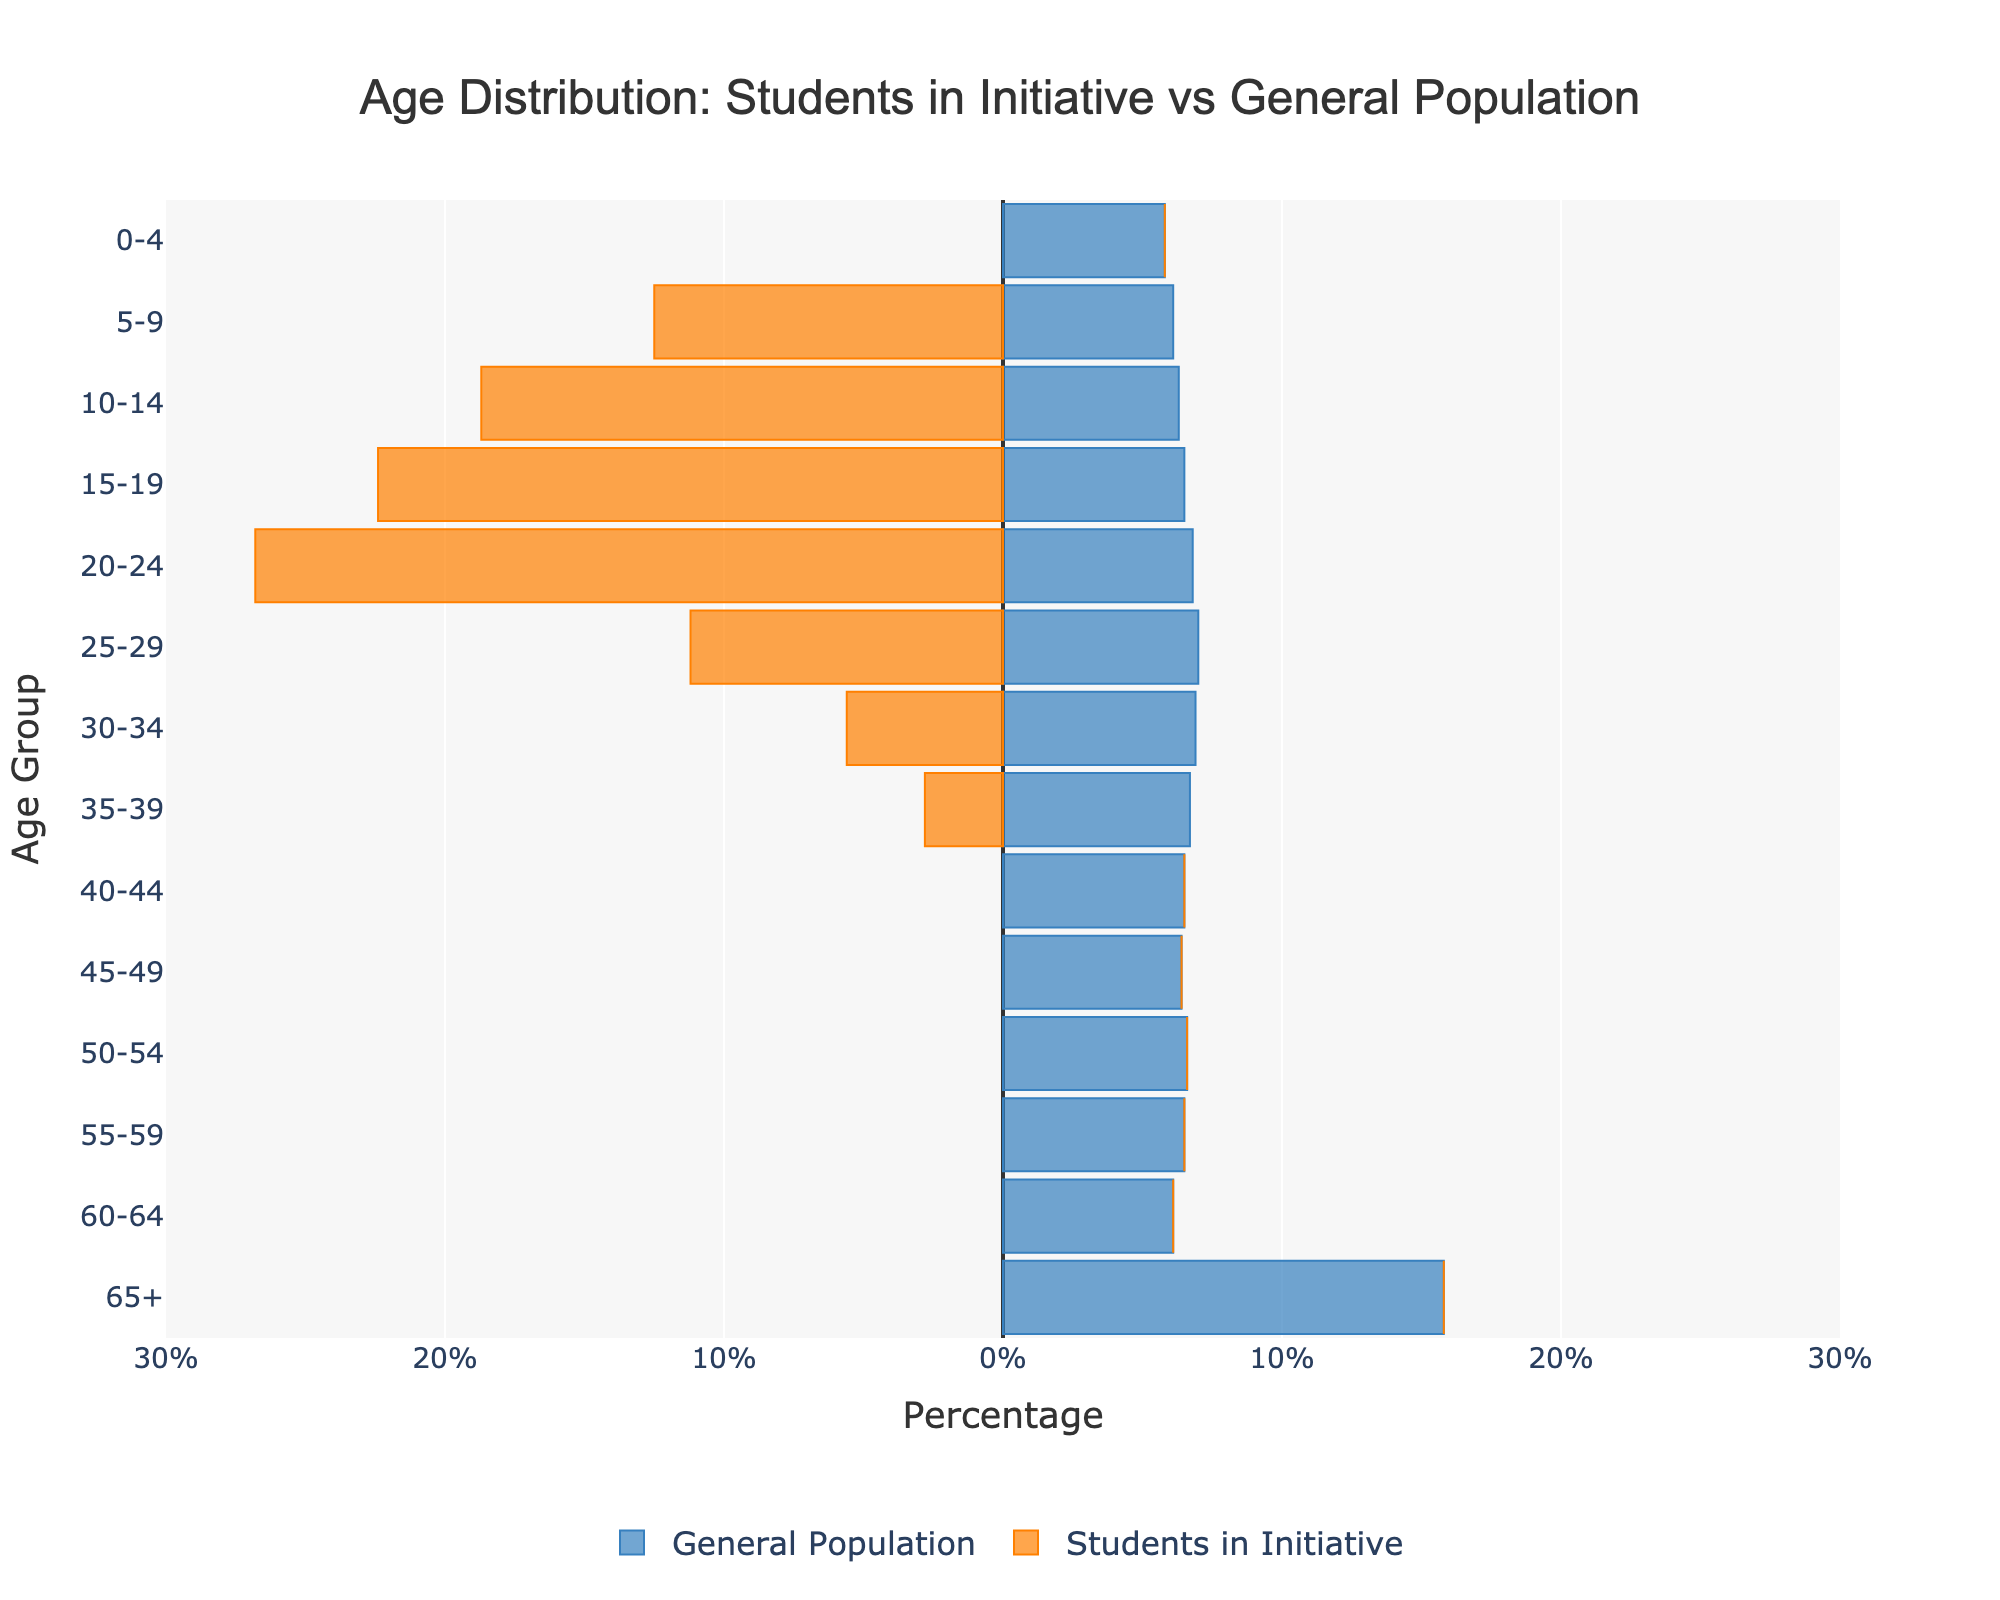What is the title of the figure? The title of the figure is displayed at the top and summarizes the content of the plot, indicating it compares age distribution of students in the educational initiative with the general population.
Answer: Age Distribution: Students in Initiative vs General Population Which age group has the highest percentage of students in the initiative? The age group with the largest negative bar for "Students in Initiative" indicates the highest percentage. Look at the "Students in Initiative" section and identify the longest bar.
Answer: 20-24 How does the percentage of the 10-14 age group in the initiative compare to the general population? Compare the length of the bars for the 10-14 age group in both "Students in Initiative" and "General Population". The "Students in Initiative" bar is much longer.
Answer: Higher in the initiative Which age group is missing from the students in the initiative but present in the general population? Identify age groups where there are no bars (0%) for "Students in Initiative" but bars exist for "General Population".
Answer: 0-4, 40-65+ What is the difference in percentage between students in the initiative and the general population for the 15-19 age group? Find the percentages for both groups in the 15-19 age range and calculate the absolute difference.
Answer: 22.4 - 6.5 = 15.9 What is the percentage of the general population for the age group 30-34? Look at the bar length for the age group 30-34 in the "General Population" section and read the percentage value.
Answer: 6.9% Is there any age group where the percentage in the general population is below 5%? Check the percentages for all age groups in the "General Population" bars to identify any below 5%.
Answer: No What can you infer about the age focus of the educational initiative based on the plot? Analyze the age distribution bars for "Students in Initiative" to identify the focus. The highest percentages are in the age groups typically associated with school-age and early adulthood, indicating a focus on these age groups.
Answer: School-age and early adulthood Which has a wider age distribution, the educational initiative or the general population? Compare the spread of the bars for both groups. The general population has bars across all age groups, while the initiative is concentrated in younger age groups.
Answer: General population How many age groups have a percentage of 0% for both "Students in Initiative" and "General Population"? Examine the bars for both groups and count the age groups with 0% in both sections.
Answer: None 